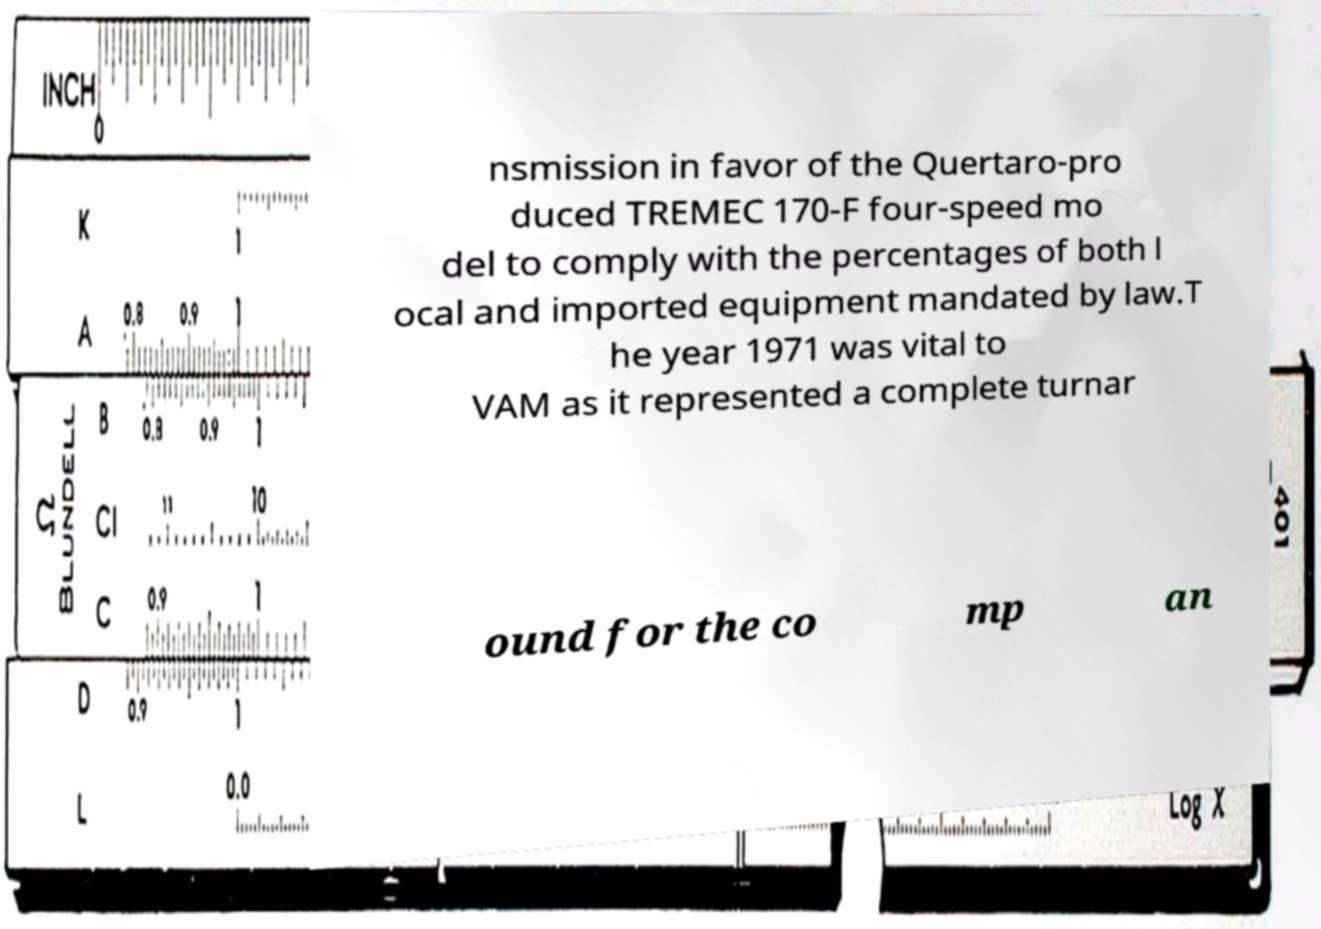Could you assist in decoding the text presented in this image and type it out clearly? nsmission in favor of the Quertaro-pro duced TREMEC 170-F four-speed mo del to comply with the percentages of both l ocal and imported equipment mandated by law.T he year 1971 was vital to VAM as it represented a complete turnar ound for the co mp an 